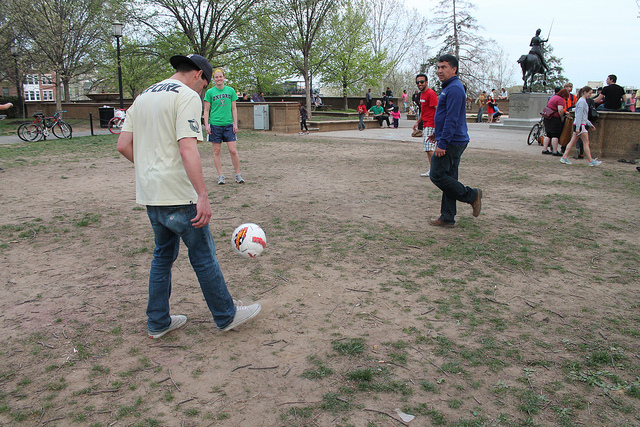<image>What is on the air? I am not sure what is on the air. It can be a ball or a soccer ball or nothing. What is on the air? I am not sure what is on the air. It can be a ball or a soccer ball. 